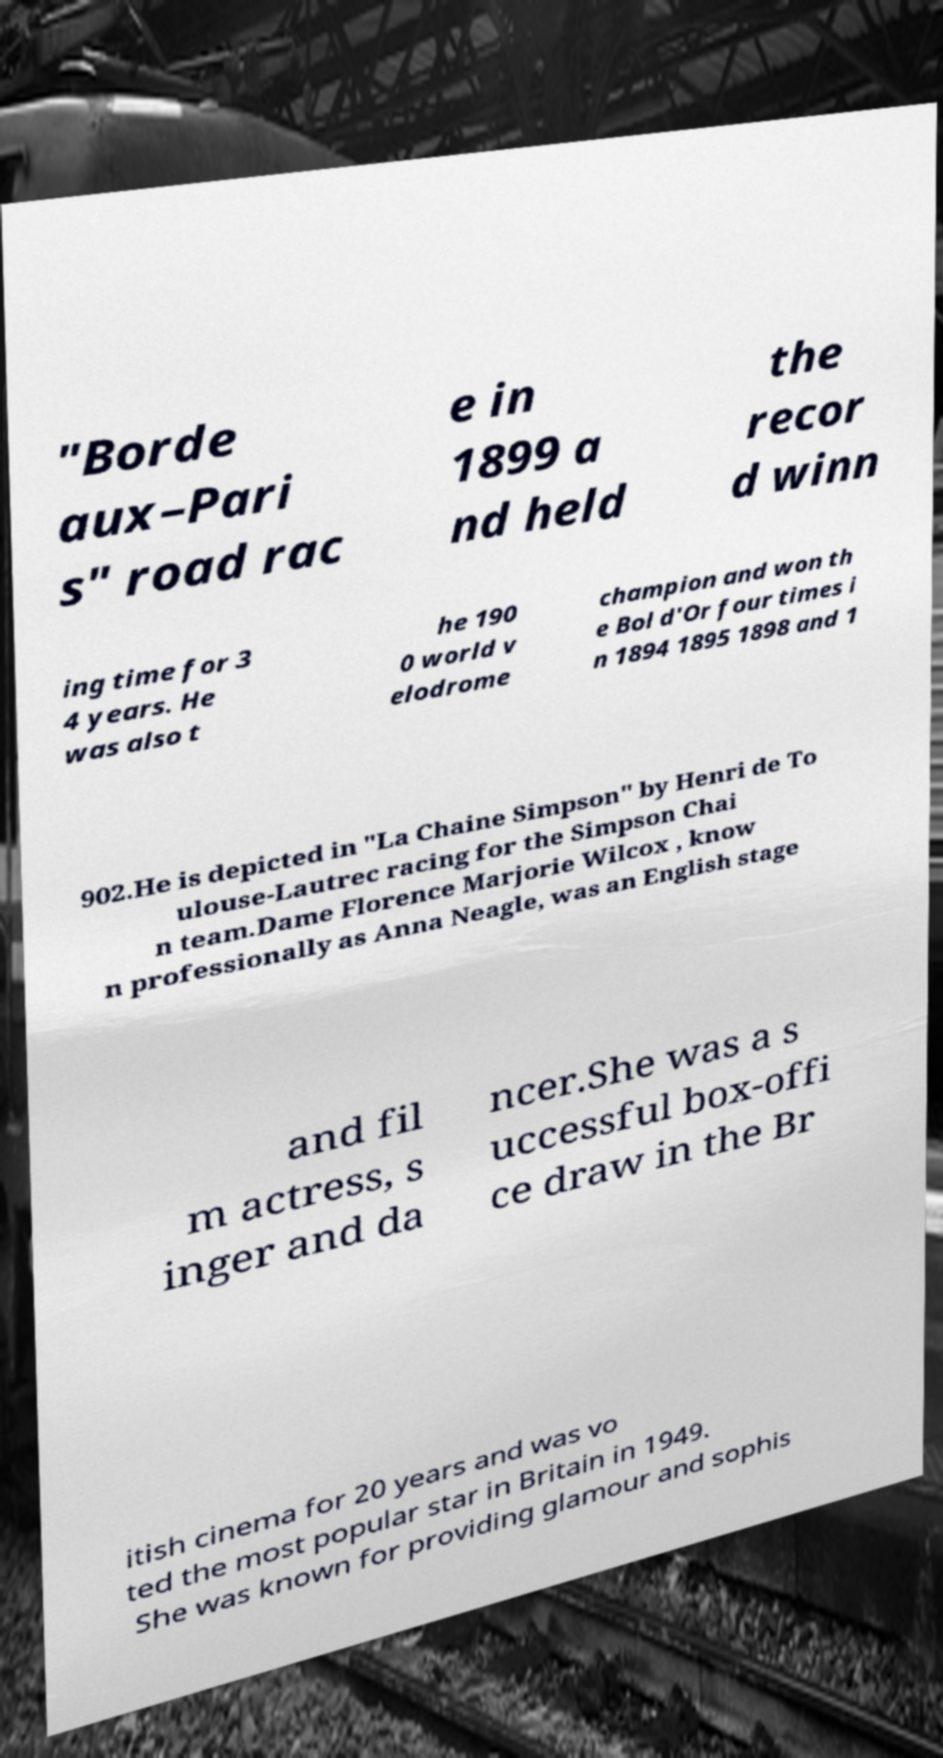Please read and relay the text visible in this image. What does it say? "Borde aux–Pari s" road rac e in 1899 a nd held the recor d winn ing time for 3 4 years. He was also t he 190 0 world v elodrome champion and won th e Bol d'Or four times i n 1894 1895 1898 and 1 902.He is depicted in "La Chaine Simpson" by Henri de To ulouse-Lautrec racing for the Simpson Chai n team.Dame Florence Marjorie Wilcox , know n professionally as Anna Neagle, was an English stage and fil m actress, s inger and da ncer.She was a s uccessful box-offi ce draw in the Br itish cinema for 20 years and was vo ted the most popular star in Britain in 1949. She was known for providing glamour and sophis 